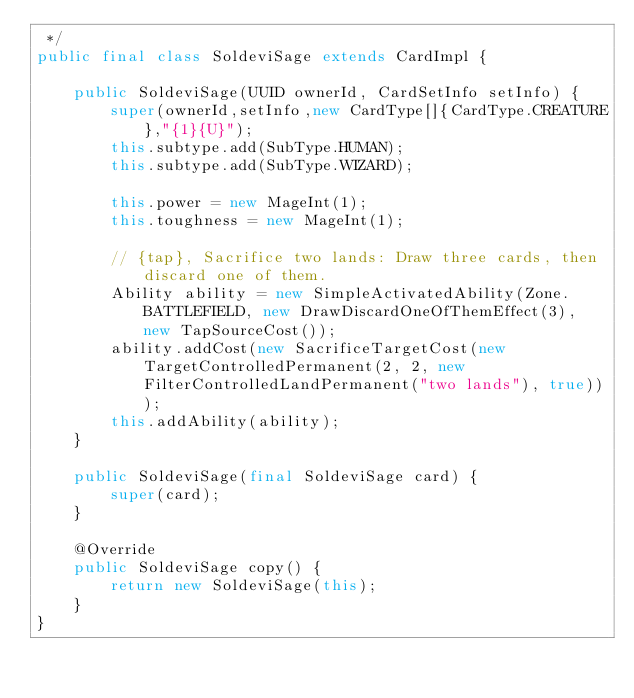Convert code to text. <code><loc_0><loc_0><loc_500><loc_500><_Java_> */
public final class SoldeviSage extends CardImpl {

    public SoldeviSage(UUID ownerId, CardSetInfo setInfo) {
        super(ownerId,setInfo,new CardType[]{CardType.CREATURE},"{1}{U}");
        this.subtype.add(SubType.HUMAN);
        this.subtype.add(SubType.WIZARD);

        this.power = new MageInt(1);
        this.toughness = new MageInt(1);

        // {tap}, Sacrifice two lands: Draw three cards, then discard one of them.
        Ability ability = new SimpleActivatedAbility(Zone.BATTLEFIELD, new DrawDiscardOneOfThemEffect(3), new TapSourceCost());
        ability.addCost(new SacrificeTargetCost(new TargetControlledPermanent(2, 2, new FilterControlledLandPermanent("two lands"), true)));
        this.addAbility(ability);
    }

    public SoldeviSage(final SoldeviSage card) {
        super(card);
    }

    @Override
    public SoldeviSage copy() {
        return new SoldeviSage(this);
    }
}</code> 